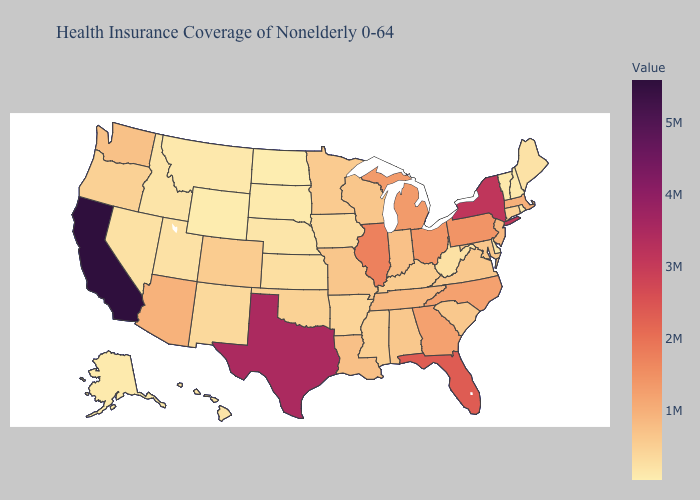Does California have the highest value in the USA?
Give a very brief answer. Yes. Does Tennessee have a higher value than California?
Keep it brief. No. Does New York have a higher value than Kentucky?
Write a very short answer. Yes. Which states have the lowest value in the USA?
Give a very brief answer. North Dakota. Among the states that border Mississippi , which have the highest value?
Concise answer only. Tennessee. Which states have the lowest value in the USA?
Short answer required. North Dakota. Among the states that border Idaho , which have the lowest value?
Answer briefly. Wyoming. 